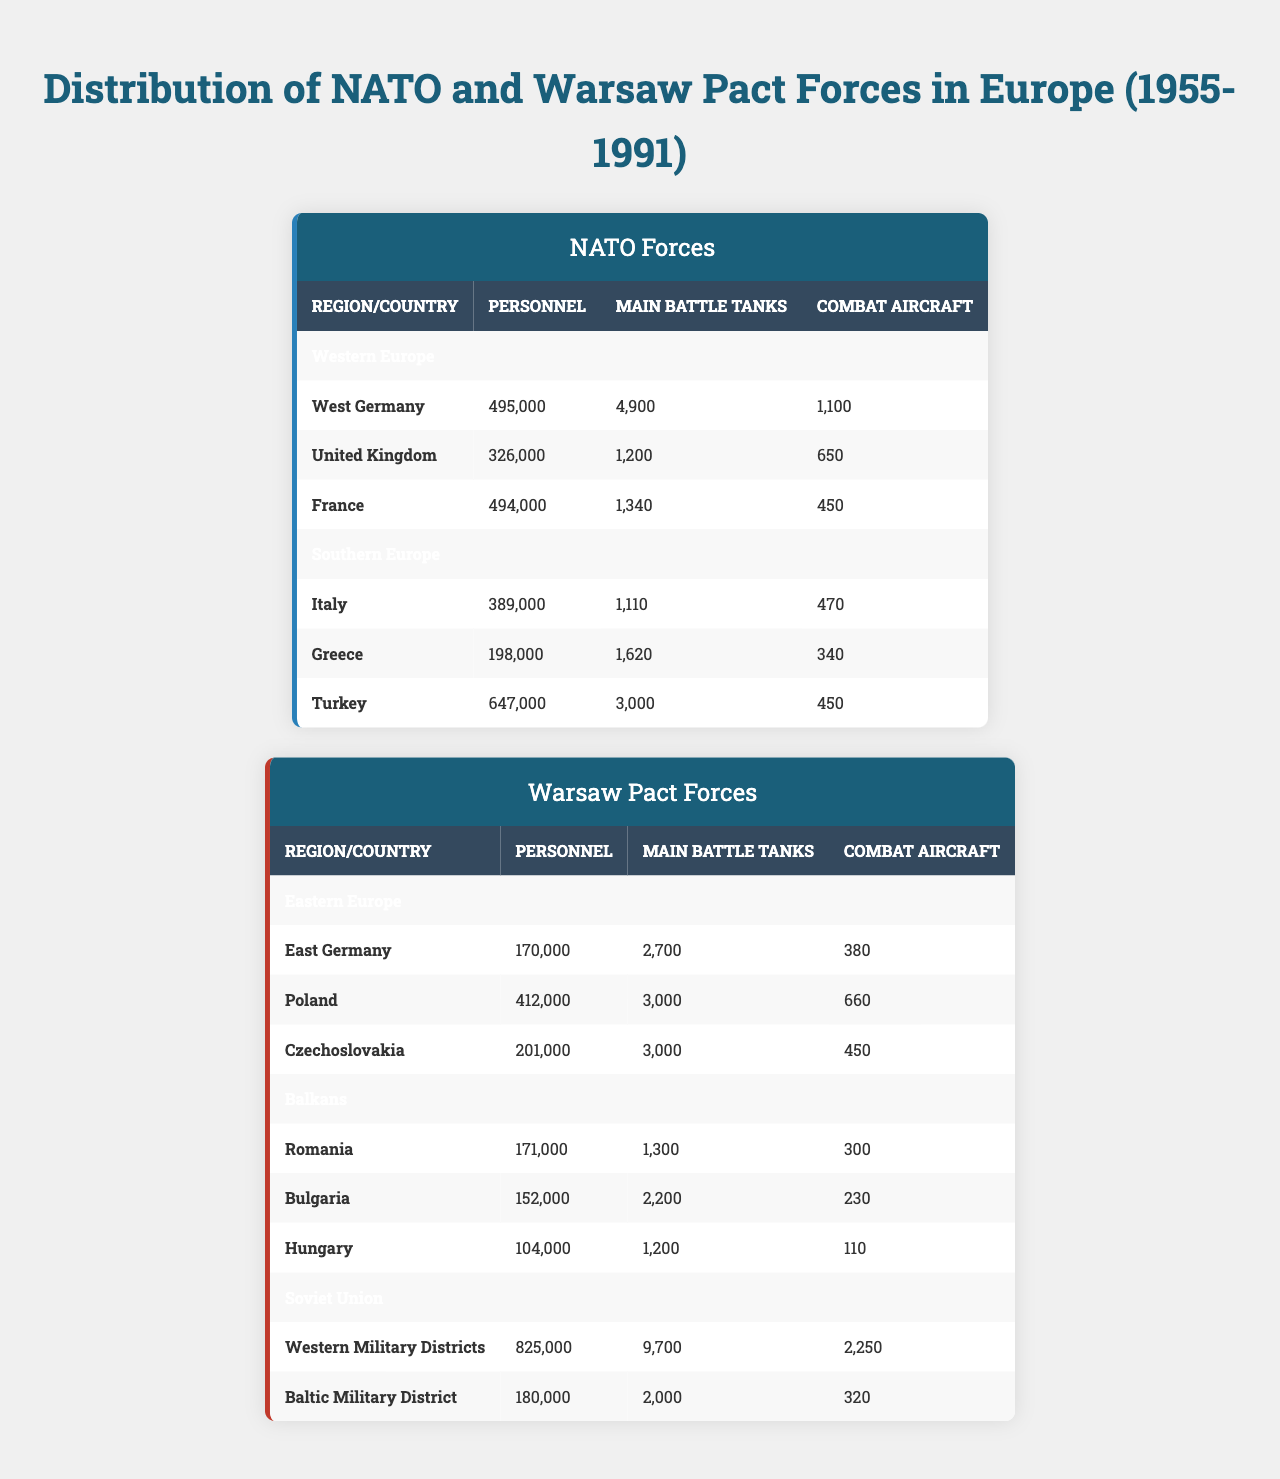What is the total personnel in NATO forces in Western Europe? In Western Europe, the total personnel for NATO forces can be calculated by adding the personnel from West Germany (495,000), the United Kingdom (326,000), and France (494,000). The sum is 495,000 + 326,000 + 494,000 = 1,315,000.
Answer: 1,315,000 Which country has the highest number of Main Battle Tanks in NATO forces? Among the NATO forces, West Germany has the highest number of Main Battle Tanks, totaling 4,900, compared to the United Kingdom (1,200) and France (1,340).
Answer: West Germany Does Turkey have more personnel than Poland? Yes, Turkey has 647,000 personnel, which is greater than Poland's 412,000 personnel.
Answer: Yes What is the average number of Combat Aircraft for Warsaw Pact forces in the Balkans? The average number of Combat Aircraft for Warsaw Pact forces in the Balkans is calculated by summing the aircraft numbers: Romania (300), Bulgaria (230), and Hungary (110), which totals 640. Dividing by the number of countries (3) gives 640 / 3 = 213.33.
Answer: 213.33 How many more Main Battle Tanks does the Soviet Union have compared to NATO forces in Southern Europe? The Soviet Union has a total of 11,700 Main Battle Tanks (Western Military District 9,700 + Baltic Military District 2,000), and NATO forces in Southern Europe have a total of 4,700 (Italy 1,110 + Greece 1,620 + Turkey 3,000). Therefore, 11,700 - 4,700 = 7,000 more tanks.
Answer: 7,000 Which alliance has a greater total number of personnel in Europe? The total personnel for NATO forces is 2,962,000 (1,315,000 in Western Europe + 1,234,000 in Southern Europe), while the Warsaw Pact forces total 1,480,000 (1,746,000 in Eastern Europe + 427,000 in the Balkans + 1,005,900 in the Soviet Union). Since 2,962,000 is greater than 1,480,000, NATO has more personnel.
Answer: NATO How many countries from NATO have more than 400,000 personnel? In NATO, only two countries have more than 400,000 personnel: West Germany (495,000) and France (494,000). The United Kingdom and the other Southern European countries do not exceed 400,000.
Answer: 2 What is the ratio of Combat Aircraft in East Germany to those in the United Kingdom? East Germany has 380 Combat Aircraft while the United Kingdom has 650. The ratio is calculated as 380:650 or simplified to approximately 0.58:1.
Answer: 0.58:1 Is it true that all Warsaw Pact countries have more Main Battle Tanks than NATO countries in the same regions? No, this is false. For instance, in Southern Europe, Turkey (3,000 tanks) has more than Romania (1,300 tanks) and Bulgaria (2,200 tanks).
Answer: No What is the total number of Combat Aircraft for NATO forces in Southern Europe? The total number of Combat Aircraft for NATO forces in Southern Europe is calculated by adding Italy (470), Greece (340), and Turkey (450). The sum is 470 + 340 + 450 = 1,260.
Answer: 1,260 